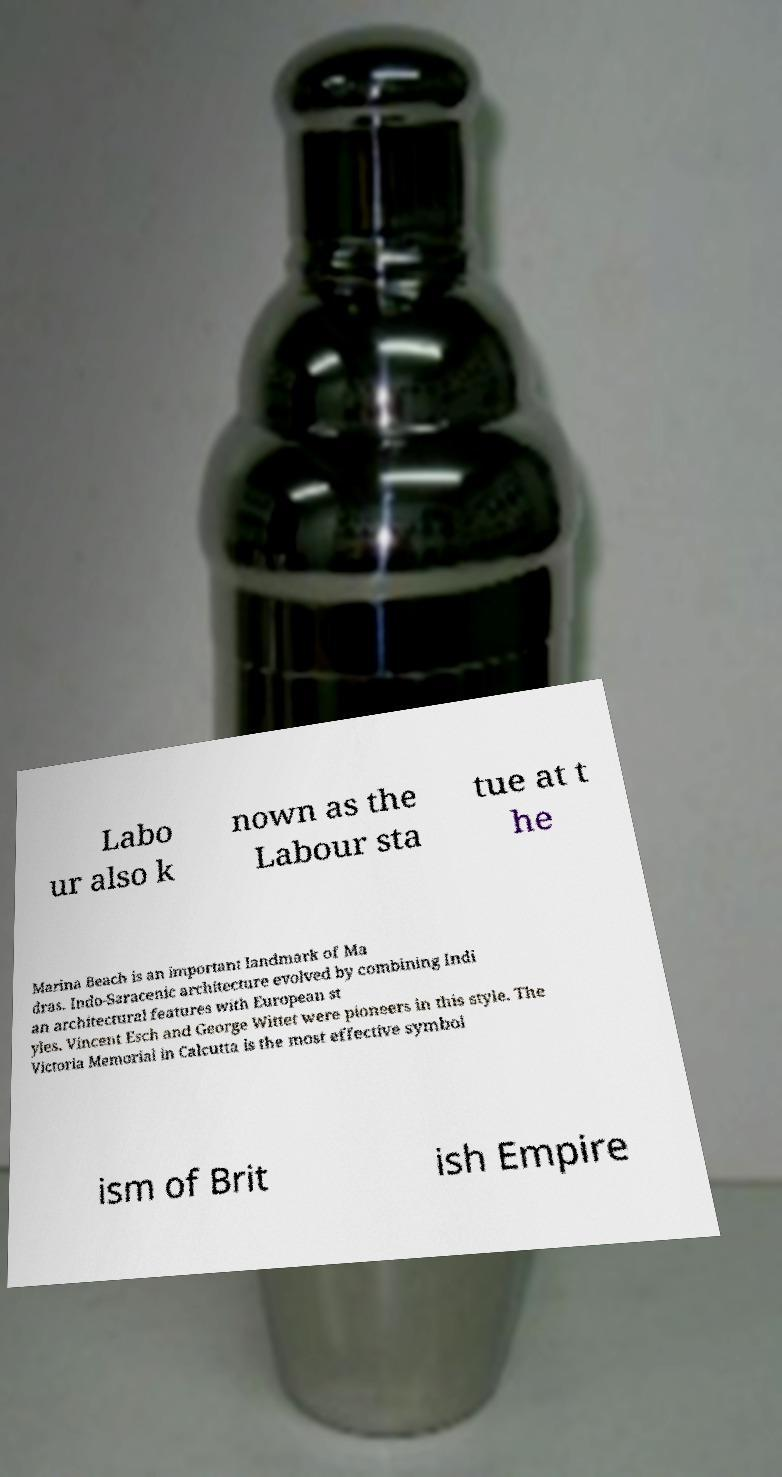I need the written content from this picture converted into text. Can you do that? Labo ur also k nown as the Labour sta tue at t he Marina Beach is an important landmark of Ma dras. Indo-Saracenic architecture evolved by combining Indi an architectural features with European st yles. Vincent Esch and George Wittet were pioneers in this style. The Victoria Memorial in Calcutta is the most effective symbol ism of Brit ish Empire 